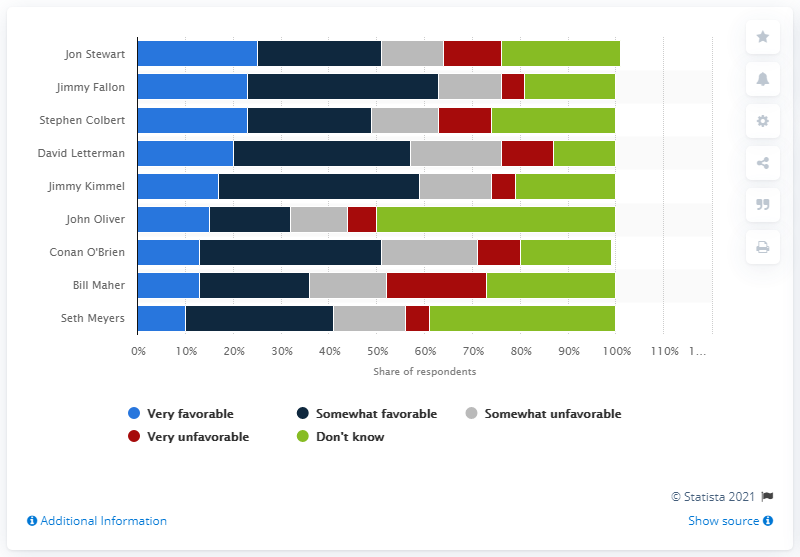Give some essential details in this illustration. Jon Stewart is the host of The Daily Show. 